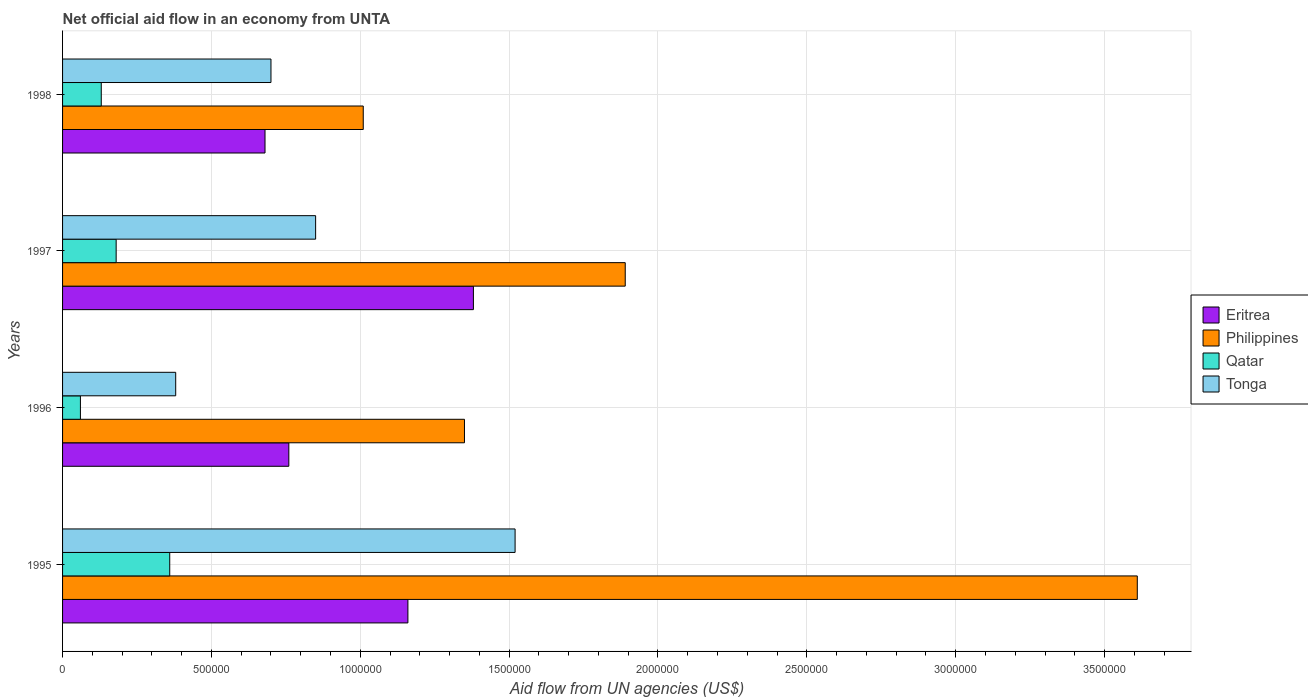Are the number of bars per tick equal to the number of legend labels?
Offer a very short reply. Yes. How many bars are there on the 3rd tick from the bottom?
Offer a very short reply. 4. What is the label of the 3rd group of bars from the top?
Ensure brevity in your answer.  1996. In how many cases, is the number of bars for a given year not equal to the number of legend labels?
Your answer should be very brief. 0. What is the net official aid flow in Philippines in 1995?
Provide a short and direct response. 3.61e+06. Across all years, what is the maximum net official aid flow in Eritrea?
Offer a very short reply. 1.38e+06. Across all years, what is the minimum net official aid flow in Tonga?
Your answer should be very brief. 3.80e+05. What is the total net official aid flow in Qatar in the graph?
Your answer should be compact. 7.30e+05. What is the difference between the net official aid flow in Qatar in 1996 and that in 1998?
Your answer should be compact. -7.00e+04. What is the average net official aid flow in Tonga per year?
Offer a very short reply. 8.62e+05. In the year 1996, what is the difference between the net official aid flow in Philippines and net official aid flow in Eritrea?
Your answer should be very brief. 5.90e+05. In how many years, is the net official aid flow in Qatar greater than 300000 US$?
Keep it short and to the point. 1. What is the ratio of the net official aid flow in Qatar in 1997 to that in 1998?
Offer a very short reply. 1.38. What is the difference between the highest and the lowest net official aid flow in Eritrea?
Keep it short and to the point. 7.00e+05. In how many years, is the net official aid flow in Philippines greater than the average net official aid flow in Philippines taken over all years?
Provide a succinct answer. 1. Is the sum of the net official aid flow in Tonga in 1996 and 1997 greater than the maximum net official aid flow in Qatar across all years?
Provide a succinct answer. Yes. What does the 3rd bar from the top in 1997 represents?
Ensure brevity in your answer.  Philippines. What does the 4th bar from the bottom in 1998 represents?
Provide a short and direct response. Tonga. Is it the case that in every year, the sum of the net official aid flow in Philippines and net official aid flow in Qatar is greater than the net official aid flow in Eritrea?
Provide a succinct answer. Yes. How many bars are there?
Provide a succinct answer. 16. Are all the bars in the graph horizontal?
Give a very brief answer. Yes. Does the graph contain any zero values?
Make the answer very short. No. Where does the legend appear in the graph?
Offer a terse response. Center right. How are the legend labels stacked?
Offer a terse response. Vertical. What is the title of the graph?
Keep it short and to the point. Net official aid flow in an economy from UNTA. What is the label or title of the X-axis?
Offer a terse response. Aid flow from UN agencies (US$). What is the label or title of the Y-axis?
Keep it short and to the point. Years. What is the Aid flow from UN agencies (US$) in Eritrea in 1995?
Provide a succinct answer. 1.16e+06. What is the Aid flow from UN agencies (US$) of Philippines in 1995?
Your answer should be very brief. 3.61e+06. What is the Aid flow from UN agencies (US$) in Qatar in 1995?
Make the answer very short. 3.60e+05. What is the Aid flow from UN agencies (US$) in Tonga in 1995?
Keep it short and to the point. 1.52e+06. What is the Aid flow from UN agencies (US$) in Eritrea in 1996?
Ensure brevity in your answer.  7.60e+05. What is the Aid flow from UN agencies (US$) of Philippines in 1996?
Offer a very short reply. 1.35e+06. What is the Aid flow from UN agencies (US$) in Eritrea in 1997?
Make the answer very short. 1.38e+06. What is the Aid flow from UN agencies (US$) in Philippines in 1997?
Your answer should be very brief. 1.89e+06. What is the Aid flow from UN agencies (US$) in Tonga in 1997?
Provide a succinct answer. 8.50e+05. What is the Aid flow from UN agencies (US$) of Eritrea in 1998?
Offer a terse response. 6.80e+05. What is the Aid flow from UN agencies (US$) in Philippines in 1998?
Make the answer very short. 1.01e+06. What is the Aid flow from UN agencies (US$) of Tonga in 1998?
Your response must be concise. 7.00e+05. Across all years, what is the maximum Aid flow from UN agencies (US$) in Eritrea?
Provide a succinct answer. 1.38e+06. Across all years, what is the maximum Aid flow from UN agencies (US$) in Philippines?
Ensure brevity in your answer.  3.61e+06. Across all years, what is the maximum Aid flow from UN agencies (US$) in Tonga?
Your answer should be compact. 1.52e+06. Across all years, what is the minimum Aid flow from UN agencies (US$) of Eritrea?
Provide a succinct answer. 6.80e+05. Across all years, what is the minimum Aid flow from UN agencies (US$) of Philippines?
Offer a terse response. 1.01e+06. Across all years, what is the minimum Aid flow from UN agencies (US$) in Qatar?
Ensure brevity in your answer.  6.00e+04. What is the total Aid flow from UN agencies (US$) in Eritrea in the graph?
Give a very brief answer. 3.98e+06. What is the total Aid flow from UN agencies (US$) of Philippines in the graph?
Make the answer very short. 7.86e+06. What is the total Aid flow from UN agencies (US$) in Qatar in the graph?
Your answer should be very brief. 7.30e+05. What is the total Aid flow from UN agencies (US$) of Tonga in the graph?
Offer a very short reply. 3.45e+06. What is the difference between the Aid flow from UN agencies (US$) of Eritrea in 1995 and that in 1996?
Make the answer very short. 4.00e+05. What is the difference between the Aid flow from UN agencies (US$) in Philippines in 1995 and that in 1996?
Provide a succinct answer. 2.26e+06. What is the difference between the Aid flow from UN agencies (US$) of Qatar in 1995 and that in 1996?
Keep it short and to the point. 3.00e+05. What is the difference between the Aid flow from UN agencies (US$) of Tonga in 1995 and that in 1996?
Your answer should be very brief. 1.14e+06. What is the difference between the Aid flow from UN agencies (US$) of Philippines in 1995 and that in 1997?
Provide a short and direct response. 1.72e+06. What is the difference between the Aid flow from UN agencies (US$) in Qatar in 1995 and that in 1997?
Make the answer very short. 1.80e+05. What is the difference between the Aid flow from UN agencies (US$) of Tonga in 1995 and that in 1997?
Keep it short and to the point. 6.70e+05. What is the difference between the Aid flow from UN agencies (US$) in Philippines in 1995 and that in 1998?
Your answer should be compact. 2.60e+06. What is the difference between the Aid flow from UN agencies (US$) of Tonga in 1995 and that in 1998?
Provide a short and direct response. 8.20e+05. What is the difference between the Aid flow from UN agencies (US$) in Eritrea in 1996 and that in 1997?
Your answer should be very brief. -6.20e+05. What is the difference between the Aid flow from UN agencies (US$) of Philippines in 1996 and that in 1997?
Your response must be concise. -5.40e+05. What is the difference between the Aid flow from UN agencies (US$) in Qatar in 1996 and that in 1997?
Your response must be concise. -1.20e+05. What is the difference between the Aid flow from UN agencies (US$) in Tonga in 1996 and that in 1997?
Offer a terse response. -4.70e+05. What is the difference between the Aid flow from UN agencies (US$) in Tonga in 1996 and that in 1998?
Your answer should be compact. -3.20e+05. What is the difference between the Aid flow from UN agencies (US$) in Philippines in 1997 and that in 1998?
Ensure brevity in your answer.  8.80e+05. What is the difference between the Aid flow from UN agencies (US$) of Eritrea in 1995 and the Aid flow from UN agencies (US$) of Philippines in 1996?
Provide a succinct answer. -1.90e+05. What is the difference between the Aid flow from UN agencies (US$) in Eritrea in 1995 and the Aid flow from UN agencies (US$) in Qatar in 1996?
Offer a very short reply. 1.10e+06. What is the difference between the Aid flow from UN agencies (US$) in Eritrea in 1995 and the Aid flow from UN agencies (US$) in Tonga in 1996?
Give a very brief answer. 7.80e+05. What is the difference between the Aid flow from UN agencies (US$) of Philippines in 1995 and the Aid flow from UN agencies (US$) of Qatar in 1996?
Your answer should be very brief. 3.55e+06. What is the difference between the Aid flow from UN agencies (US$) in Philippines in 1995 and the Aid flow from UN agencies (US$) in Tonga in 1996?
Keep it short and to the point. 3.23e+06. What is the difference between the Aid flow from UN agencies (US$) in Eritrea in 1995 and the Aid flow from UN agencies (US$) in Philippines in 1997?
Provide a short and direct response. -7.30e+05. What is the difference between the Aid flow from UN agencies (US$) in Eritrea in 1995 and the Aid flow from UN agencies (US$) in Qatar in 1997?
Offer a terse response. 9.80e+05. What is the difference between the Aid flow from UN agencies (US$) in Philippines in 1995 and the Aid flow from UN agencies (US$) in Qatar in 1997?
Keep it short and to the point. 3.43e+06. What is the difference between the Aid flow from UN agencies (US$) in Philippines in 1995 and the Aid flow from UN agencies (US$) in Tonga in 1997?
Your answer should be very brief. 2.76e+06. What is the difference between the Aid flow from UN agencies (US$) of Qatar in 1995 and the Aid flow from UN agencies (US$) of Tonga in 1997?
Your answer should be very brief. -4.90e+05. What is the difference between the Aid flow from UN agencies (US$) of Eritrea in 1995 and the Aid flow from UN agencies (US$) of Philippines in 1998?
Give a very brief answer. 1.50e+05. What is the difference between the Aid flow from UN agencies (US$) of Eritrea in 1995 and the Aid flow from UN agencies (US$) of Qatar in 1998?
Provide a short and direct response. 1.03e+06. What is the difference between the Aid flow from UN agencies (US$) of Philippines in 1995 and the Aid flow from UN agencies (US$) of Qatar in 1998?
Your answer should be very brief. 3.48e+06. What is the difference between the Aid flow from UN agencies (US$) of Philippines in 1995 and the Aid flow from UN agencies (US$) of Tonga in 1998?
Offer a terse response. 2.91e+06. What is the difference between the Aid flow from UN agencies (US$) in Eritrea in 1996 and the Aid flow from UN agencies (US$) in Philippines in 1997?
Give a very brief answer. -1.13e+06. What is the difference between the Aid flow from UN agencies (US$) in Eritrea in 1996 and the Aid flow from UN agencies (US$) in Qatar in 1997?
Your answer should be compact. 5.80e+05. What is the difference between the Aid flow from UN agencies (US$) in Philippines in 1996 and the Aid flow from UN agencies (US$) in Qatar in 1997?
Ensure brevity in your answer.  1.17e+06. What is the difference between the Aid flow from UN agencies (US$) in Qatar in 1996 and the Aid flow from UN agencies (US$) in Tonga in 1997?
Offer a terse response. -7.90e+05. What is the difference between the Aid flow from UN agencies (US$) of Eritrea in 1996 and the Aid flow from UN agencies (US$) of Qatar in 1998?
Your response must be concise. 6.30e+05. What is the difference between the Aid flow from UN agencies (US$) of Eritrea in 1996 and the Aid flow from UN agencies (US$) of Tonga in 1998?
Offer a very short reply. 6.00e+04. What is the difference between the Aid flow from UN agencies (US$) in Philippines in 1996 and the Aid flow from UN agencies (US$) in Qatar in 1998?
Your response must be concise. 1.22e+06. What is the difference between the Aid flow from UN agencies (US$) in Philippines in 1996 and the Aid flow from UN agencies (US$) in Tonga in 1998?
Your answer should be very brief. 6.50e+05. What is the difference between the Aid flow from UN agencies (US$) of Qatar in 1996 and the Aid flow from UN agencies (US$) of Tonga in 1998?
Keep it short and to the point. -6.40e+05. What is the difference between the Aid flow from UN agencies (US$) in Eritrea in 1997 and the Aid flow from UN agencies (US$) in Qatar in 1998?
Provide a succinct answer. 1.25e+06. What is the difference between the Aid flow from UN agencies (US$) in Eritrea in 1997 and the Aid flow from UN agencies (US$) in Tonga in 1998?
Offer a terse response. 6.80e+05. What is the difference between the Aid flow from UN agencies (US$) of Philippines in 1997 and the Aid flow from UN agencies (US$) of Qatar in 1998?
Provide a short and direct response. 1.76e+06. What is the difference between the Aid flow from UN agencies (US$) in Philippines in 1997 and the Aid flow from UN agencies (US$) in Tonga in 1998?
Your response must be concise. 1.19e+06. What is the difference between the Aid flow from UN agencies (US$) of Qatar in 1997 and the Aid flow from UN agencies (US$) of Tonga in 1998?
Your answer should be very brief. -5.20e+05. What is the average Aid flow from UN agencies (US$) of Eritrea per year?
Give a very brief answer. 9.95e+05. What is the average Aid flow from UN agencies (US$) in Philippines per year?
Your response must be concise. 1.96e+06. What is the average Aid flow from UN agencies (US$) of Qatar per year?
Keep it short and to the point. 1.82e+05. What is the average Aid flow from UN agencies (US$) in Tonga per year?
Ensure brevity in your answer.  8.62e+05. In the year 1995, what is the difference between the Aid flow from UN agencies (US$) of Eritrea and Aid flow from UN agencies (US$) of Philippines?
Make the answer very short. -2.45e+06. In the year 1995, what is the difference between the Aid flow from UN agencies (US$) of Eritrea and Aid flow from UN agencies (US$) of Tonga?
Your answer should be compact. -3.60e+05. In the year 1995, what is the difference between the Aid flow from UN agencies (US$) in Philippines and Aid flow from UN agencies (US$) in Qatar?
Offer a terse response. 3.25e+06. In the year 1995, what is the difference between the Aid flow from UN agencies (US$) in Philippines and Aid flow from UN agencies (US$) in Tonga?
Keep it short and to the point. 2.09e+06. In the year 1995, what is the difference between the Aid flow from UN agencies (US$) in Qatar and Aid flow from UN agencies (US$) in Tonga?
Your answer should be compact. -1.16e+06. In the year 1996, what is the difference between the Aid flow from UN agencies (US$) in Eritrea and Aid flow from UN agencies (US$) in Philippines?
Offer a terse response. -5.90e+05. In the year 1996, what is the difference between the Aid flow from UN agencies (US$) in Eritrea and Aid flow from UN agencies (US$) in Qatar?
Offer a very short reply. 7.00e+05. In the year 1996, what is the difference between the Aid flow from UN agencies (US$) in Philippines and Aid flow from UN agencies (US$) in Qatar?
Provide a short and direct response. 1.29e+06. In the year 1996, what is the difference between the Aid flow from UN agencies (US$) in Philippines and Aid flow from UN agencies (US$) in Tonga?
Keep it short and to the point. 9.70e+05. In the year 1996, what is the difference between the Aid flow from UN agencies (US$) of Qatar and Aid flow from UN agencies (US$) of Tonga?
Your response must be concise. -3.20e+05. In the year 1997, what is the difference between the Aid flow from UN agencies (US$) in Eritrea and Aid flow from UN agencies (US$) in Philippines?
Offer a very short reply. -5.10e+05. In the year 1997, what is the difference between the Aid flow from UN agencies (US$) of Eritrea and Aid flow from UN agencies (US$) of Qatar?
Make the answer very short. 1.20e+06. In the year 1997, what is the difference between the Aid flow from UN agencies (US$) in Eritrea and Aid flow from UN agencies (US$) in Tonga?
Provide a short and direct response. 5.30e+05. In the year 1997, what is the difference between the Aid flow from UN agencies (US$) in Philippines and Aid flow from UN agencies (US$) in Qatar?
Offer a terse response. 1.71e+06. In the year 1997, what is the difference between the Aid flow from UN agencies (US$) of Philippines and Aid flow from UN agencies (US$) of Tonga?
Keep it short and to the point. 1.04e+06. In the year 1997, what is the difference between the Aid flow from UN agencies (US$) of Qatar and Aid flow from UN agencies (US$) of Tonga?
Provide a succinct answer. -6.70e+05. In the year 1998, what is the difference between the Aid flow from UN agencies (US$) of Eritrea and Aid flow from UN agencies (US$) of Philippines?
Provide a short and direct response. -3.30e+05. In the year 1998, what is the difference between the Aid flow from UN agencies (US$) in Eritrea and Aid flow from UN agencies (US$) in Tonga?
Offer a terse response. -2.00e+04. In the year 1998, what is the difference between the Aid flow from UN agencies (US$) in Philippines and Aid flow from UN agencies (US$) in Qatar?
Your response must be concise. 8.80e+05. In the year 1998, what is the difference between the Aid flow from UN agencies (US$) of Philippines and Aid flow from UN agencies (US$) of Tonga?
Your answer should be compact. 3.10e+05. In the year 1998, what is the difference between the Aid flow from UN agencies (US$) in Qatar and Aid flow from UN agencies (US$) in Tonga?
Give a very brief answer. -5.70e+05. What is the ratio of the Aid flow from UN agencies (US$) of Eritrea in 1995 to that in 1996?
Ensure brevity in your answer.  1.53. What is the ratio of the Aid flow from UN agencies (US$) of Philippines in 1995 to that in 1996?
Your answer should be very brief. 2.67. What is the ratio of the Aid flow from UN agencies (US$) in Eritrea in 1995 to that in 1997?
Your response must be concise. 0.84. What is the ratio of the Aid flow from UN agencies (US$) in Philippines in 1995 to that in 1997?
Make the answer very short. 1.91. What is the ratio of the Aid flow from UN agencies (US$) in Qatar in 1995 to that in 1997?
Ensure brevity in your answer.  2. What is the ratio of the Aid flow from UN agencies (US$) of Tonga in 1995 to that in 1997?
Your answer should be compact. 1.79. What is the ratio of the Aid flow from UN agencies (US$) in Eritrea in 1995 to that in 1998?
Your answer should be compact. 1.71. What is the ratio of the Aid flow from UN agencies (US$) of Philippines in 1995 to that in 1998?
Give a very brief answer. 3.57. What is the ratio of the Aid flow from UN agencies (US$) in Qatar in 1995 to that in 1998?
Keep it short and to the point. 2.77. What is the ratio of the Aid flow from UN agencies (US$) in Tonga in 1995 to that in 1998?
Offer a terse response. 2.17. What is the ratio of the Aid flow from UN agencies (US$) of Eritrea in 1996 to that in 1997?
Provide a succinct answer. 0.55. What is the ratio of the Aid flow from UN agencies (US$) in Qatar in 1996 to that in 1997?
Ensure brevity in your answer.  0.33. What is the ratio of the Aid flow from UN agencies (US$) in Tonga in 1996 to that in 1997?
Make the answer very short. 0.45. What is the ratio of the Aid flow from UN agencies (US$) of Eritrea in 1996 to that in 1998?
Your response must be concise. 1.12. What is the ratio of the Aid flow from UN agencies (US$) of Philippines in 1996 to that in 1998?
Your answer should be compact. 1.34. What is the ratio of the Aid flow from UN agencies (US$) in Qatar in 1996 to that in 1998?
Make the answer very short. 0.46. What is the ratio of the Aid flow from UN agencies (US$) in Tonga in 1996 to that in 1998?
Your response must be concise. 0.54. What is the ratio of the Aid flow from UN agencies (US$) of Eritrea in 1997 to that in 1998?
Your response must be concise. 2.03. What is the ratio of the Aid flow from UN agencies (US$) in Philippines in 1997 to that in 1998?
Offer a terse response. 1.87. What is the ratio of the Aid flow from UN agencies (US$) of Qatar in 1997 to that in 1998?
Your answer should be compact. 1.38. What is the ratio of the Aid flow from UN agencies (US$) in Tonga in 1997 to that in 1998?
Provide a short and direct response. 1.21. What is the difference between the highest and the second highest Aid flow from UN agencies (US$) of Philippines?
Give a very brief answer. 1.72e+06. What is the difference between the highest and the second highest Aid flow from UN agencies (US$) of Qatar?
Make the answer very short. 1.80e+05. What is the difference between the highest and the second highest Aid flow from UN agencies (US$) of Tonga?
Ensure brevity in your answer.  6.70e+05. What is the difference between the highest and the lowest Aid flow from UN agencies (US$) of Eritrea?
Give a very brief answer. 7.00e+05. What is the difference between the highest and the lowest Aid flow from UN agencies (US$) of Philippines?
Keep it short and to the point. 2.60e+06. What is the difference between the highest and the lowest Aid flow from UN agencies (US$) in Qatar?
Make the answer very short. 3.00e+05. What is the difference between the highest and the lowest Aid flow from UN agencies (US$) of Tonga?
Provide a succinct answer. 1.14e+06. 